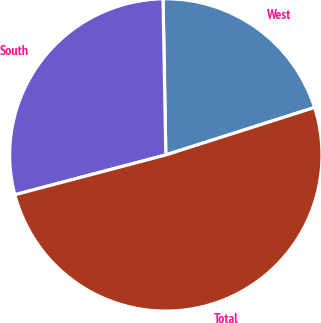<chart> <loc_0><loc_0><loc_500><loc_500><pie_chart><fcel>West<fcel>South<fcel>Total<nl><fcel>20.37%<fcel>28.82%<fcel>50.81%<nl></chart> 